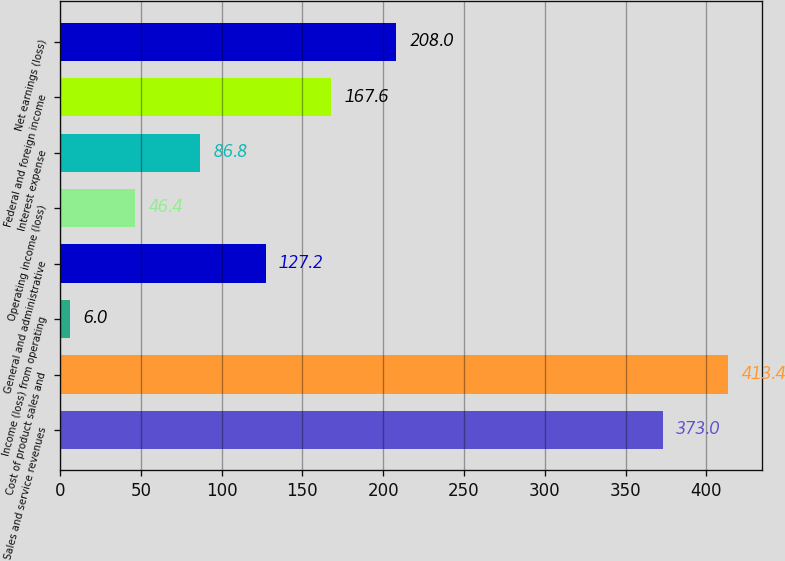Convert chart to OTSL. <chart><loc_0><loc_0><loc_500><loc_500><bar_chart><fcel>Sales and service revenues<fcel>Cost of product sales and<fcel>Income (loss) from operating<fcel>General and administrative<fcel>Operating income (loss)<fcel>Interest expense<fcel>Federal and foreign income<fcel>Net earnings (loss)<nl><fcel>373<fcel>413.4<fcel>6<fcel>127.2<fcel>46.4<fcel>86.8<fcel>167.6<fcel>208<nl></chart> 